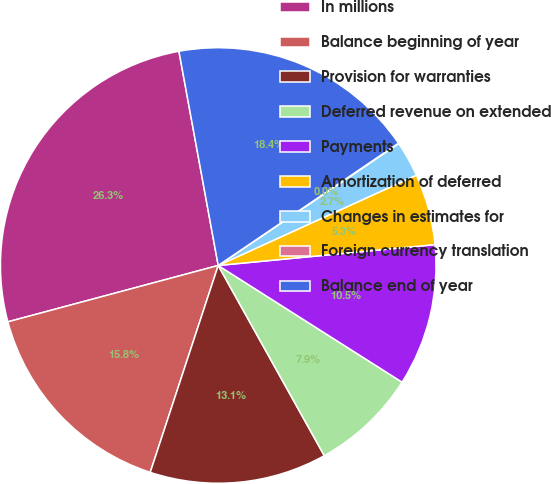Convert chart. <chart><loc_0><loc_0><loc_500><loc_500><pie_chart><fcel>In millions<fcel>Balance beginning of year<fcel>Provision for warranties<fcel>Deferred revenue on extended<fcel>Payments<fcel>Amortization of deferred<fcel>Changes in estimates for<fcel>Foreign currency translation<fcel>Balance end of year<nl><fcel>26.28%<fcel>15.78%<fcel>13.15%<fcel>7.9%<fcel>10.53%<fcel>5.28%<fcel>2.65%<fcel>0.03%<fcel>18.4%<nl></chart> 